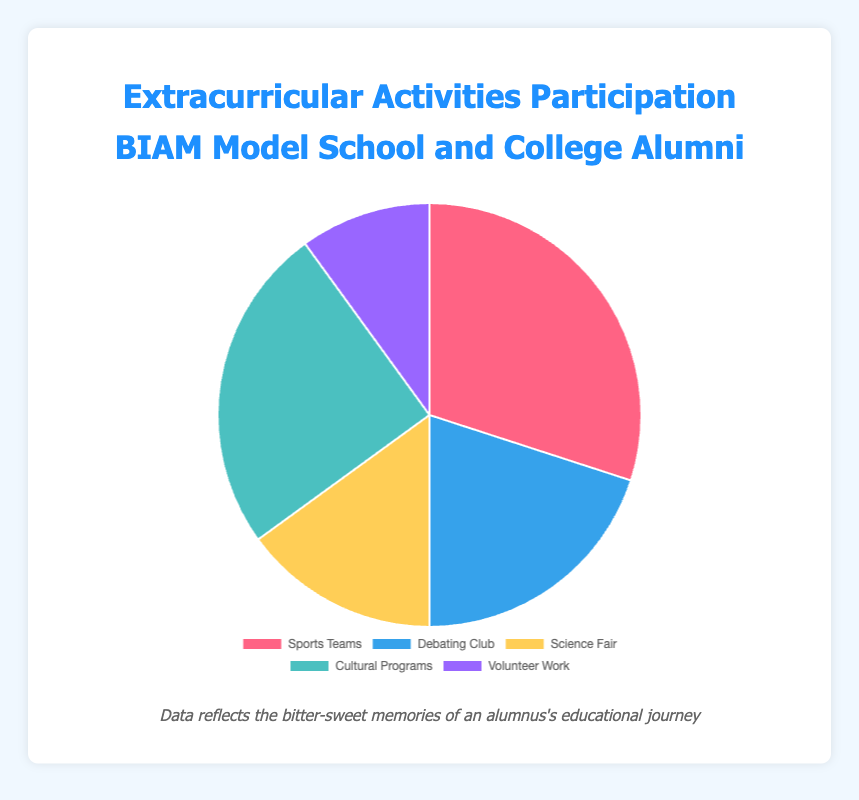What's the most participated extracurricular activity among BIAM Model School and College alumni? The pie chart shows different activities with their respective percentages. The activity with the highest percentage (30%) is Sports Teams.
Answer: Sports Teams Which two activities have a combined participation percentage of 50%? By looking at the percentages, we notice that the sum of 30% (Sports Teams) and 20% (Debating Club) equals 50%.
Answer: Sports Teams and Debating Club Is it true that less than half of the alumni participated in Cultural Programs? The chart shows that the percentage for Cultural Programs is 25%, which is less than 50%.
Answer: Yes Which activity is least participated in among the alumni? By comparing the percentages, Volunteer Work has the lowest percentage, which is 10%.
Answer: Volunteer Work How much more popular are Sports Teams compared to Science Fair? The percentage for Sports Teams is 30% and for Science Fair is 15%. The difference is 30% - 15% = 15%.
Answer: 15% What is the total percentage of alumni that participated in either Science Fair or Volunteer Work? Adding the percentages for Science Fair (15%) and Volunteer Work (10%) gives us 15% + 10% = 25%.
Answer: 25% If you combine the participation percentages of Debating Club and Cultural Programs, what fraction of the total number of activities does it represent? The sum of Debating Club and Cultural Programs participation percentages is 20% + 25% = 45%. Since the total is 100%, the fraction is 45/100 = 9/20.
Answer: 9/20 Does the participation in Sports Teams exceed the combined participation in Science Fair and Volunteer Work? The percentage for Sports Teams is 30%. The combined percentage for Science Fair and Volunteer Work is 15% + 10% = 25%. Since 30% > 25%, Sports Teams participation indeed exceeds the combined participation in Science Fair and Volunteer Work.
Answer: Yes 